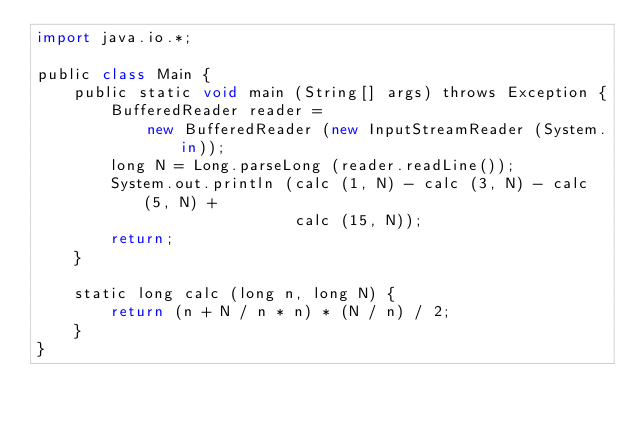<code> <loc_0><loc_0><loc_500><loc_500><_JavaScript_>import java.io.*;

public class Main {
    public static void main (String[] args) throws Exception {
        BufferedReader reader =
            new BufferedReader (new InputStreamReader (System.in));
        long N = Long.parseLong (reader.readLine());
        System.out.println (calc (1, N) - calc (3, N) - calc (5, N) +
                            calc (15, N));
        return;
    }

    static long calc (long n, long N) {
        return (n + N / n * n) * (N / n) / 2;
    }
}</code> 